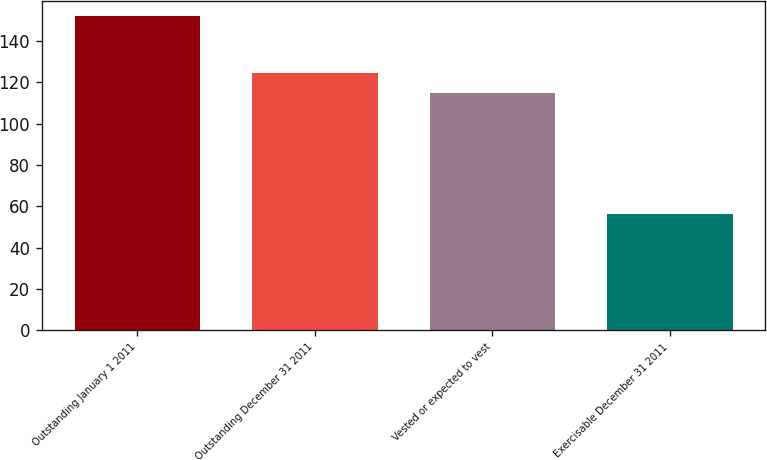<chart> <loc_0><loc_0><loc_500><loc_500><bar_chart><fcel>Outstanding January 1 2011<fcel>Outstanding December 31 2011<fcel>Vested or expected to vest<fcel>Exercisable December 31 2011<nl><fcel>152<fcel>124.6<fcel>115<fcel>56<nl></chart> 